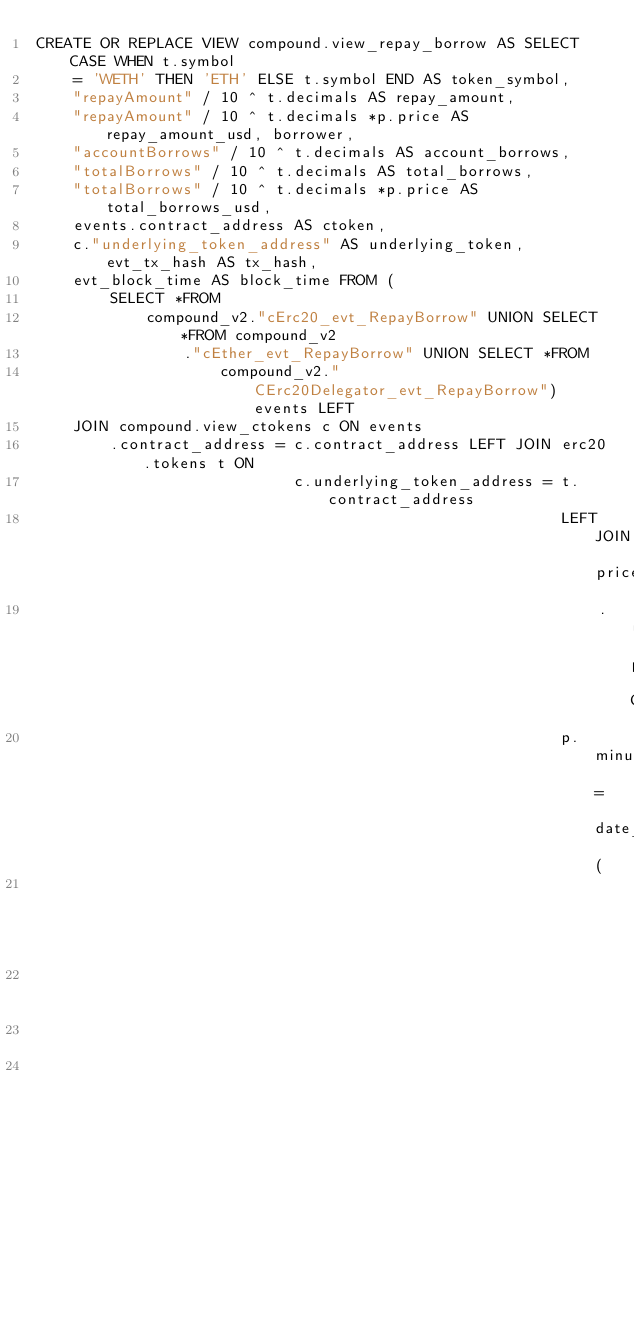Convert code to text. <code><loc_0><loc_0><loc_500><loc_500><_SQL_>CREATE OR REPLACE VIEW compound.view_repay_borrow AS SELECT CASE WHEN t.symbol
    = 'WETH' THEN 'ETH' ELSE t.symbol END AS token_symbol,
    "repayAmount" / 10 ^ t.decimals AS repay_amount,
    "repayAmount" / 10 ^ t.decimals *p.price AS repay_amount_usd, borrower,
    "accountBorrows" / 10 ^ t.decimals AS account_borrows,
    "totalBorrows" / 10 ^ t.decimals AS total_borrows,
    "totalBorrows" / 10 ^ t.decimals *p.price AS total_borrows_usd,
    events.contract_address AS ctoken,
    c."underlying_token_address" AS underlying_token, evt_tx_hash AS tx_hash,
    evt_block_time AS block_time FROM (
        SELECT *FROM
            compound_v2."cErc20_evt_RepayBorrow" UNION SELECT *FROM compound_v2
                ."cEther_evt_RepayBorrow" UNION SELECT *FROM
                    compound_v2."CErc20Delegator_evt_RepayBorrow") events LEFT
    JOIN compound.view_ctokens c ON events
        .contract_address = c.contract_address LEFT JOIN erc20.tokens t ON
                            c.underlying_token_address = t.contract_address
                                                         LEFT JOIN prices
                                                             .usd p ON
                                                         p.minute = date_trunc (
                                                                        'minute',
                                                                        evt_block_time)
                                                                        AND
                                                                    p.contract_address = c.underlying_token_address;
</code> 